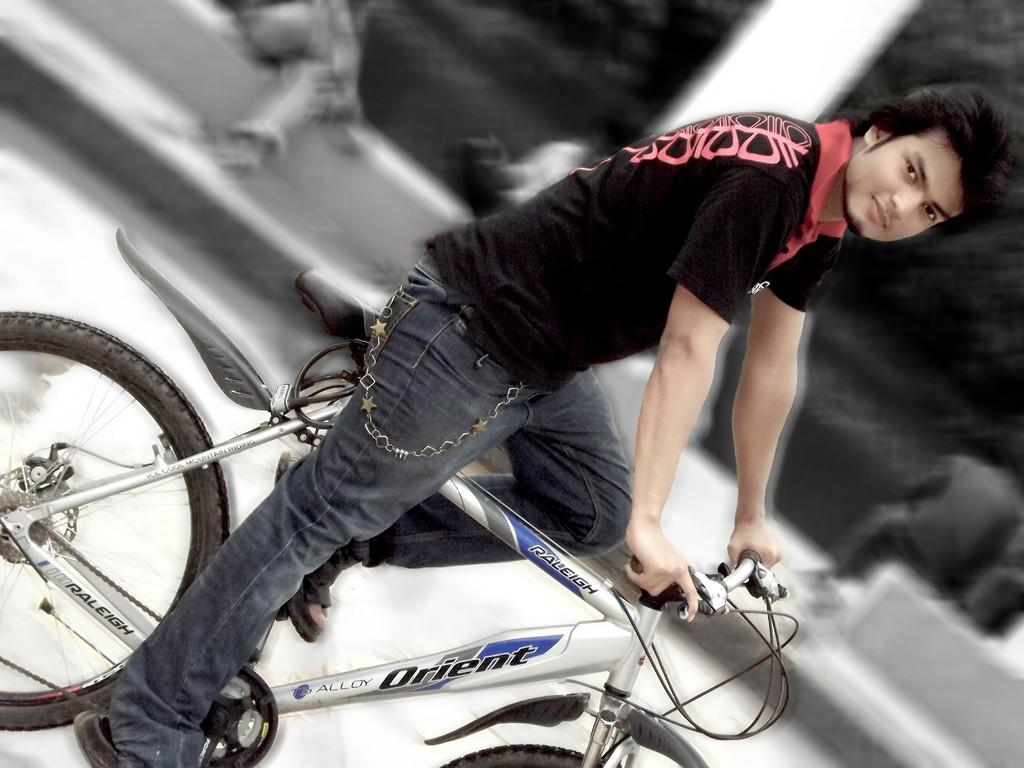Who is the main subject in the image? There is a boy in the image. What is the boy doing in the image? The boy is riding a bicycle. How many hands can be seen holding items in the store in the image? There is no store present in the image, and therefore no hands holding items can be observed. 